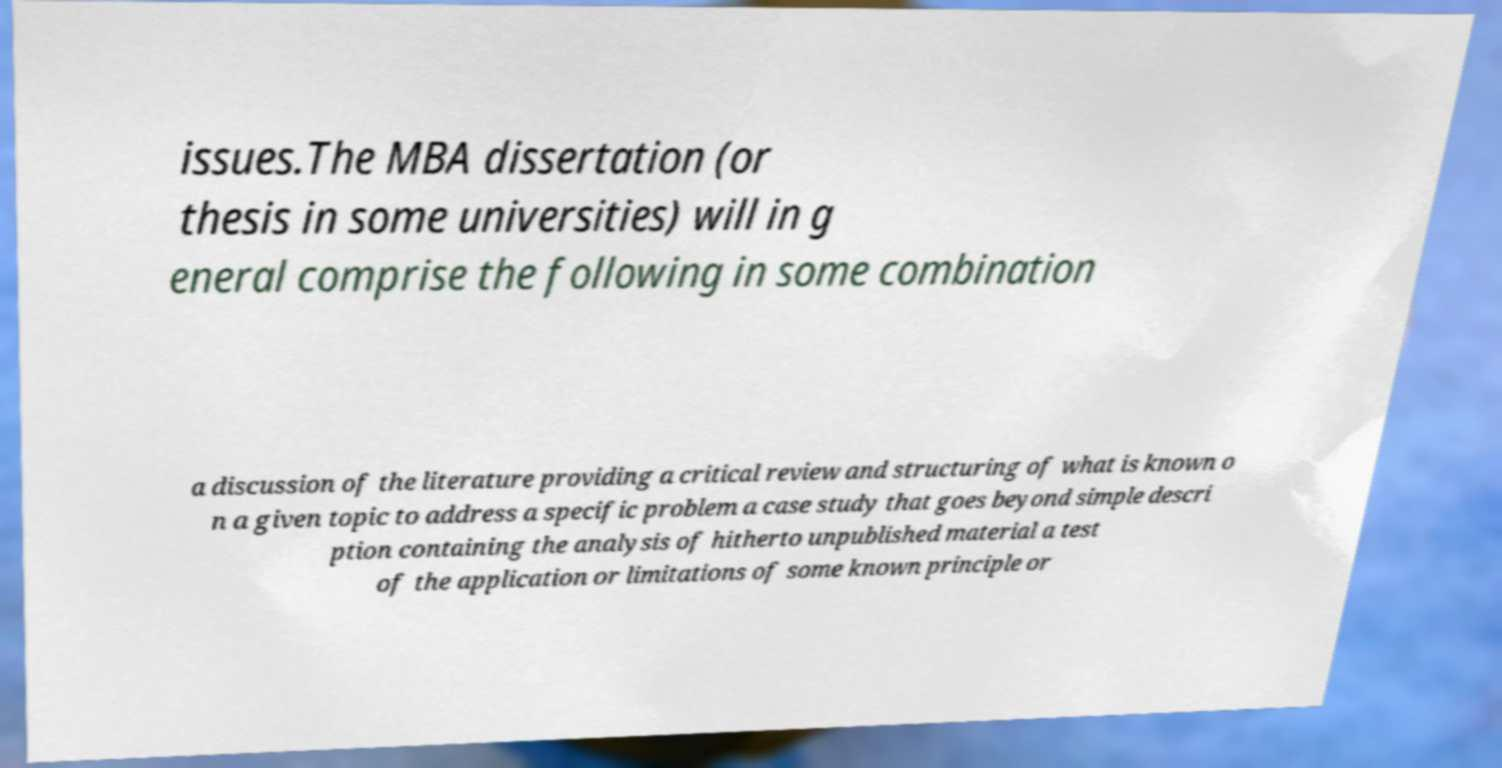Please identify and transcribe the text found in this image. issues.The MBA dissertation (or thesis in some universities) will in g eneral comprise the following in some combination a discussion of the literature providing a critical review and structuring of what is known o n a given topic to address a specific problem a case study that goes beyond simple descri ption containing the analysis of hitherto unpublished material a test of the application or limitations of some known principle or 